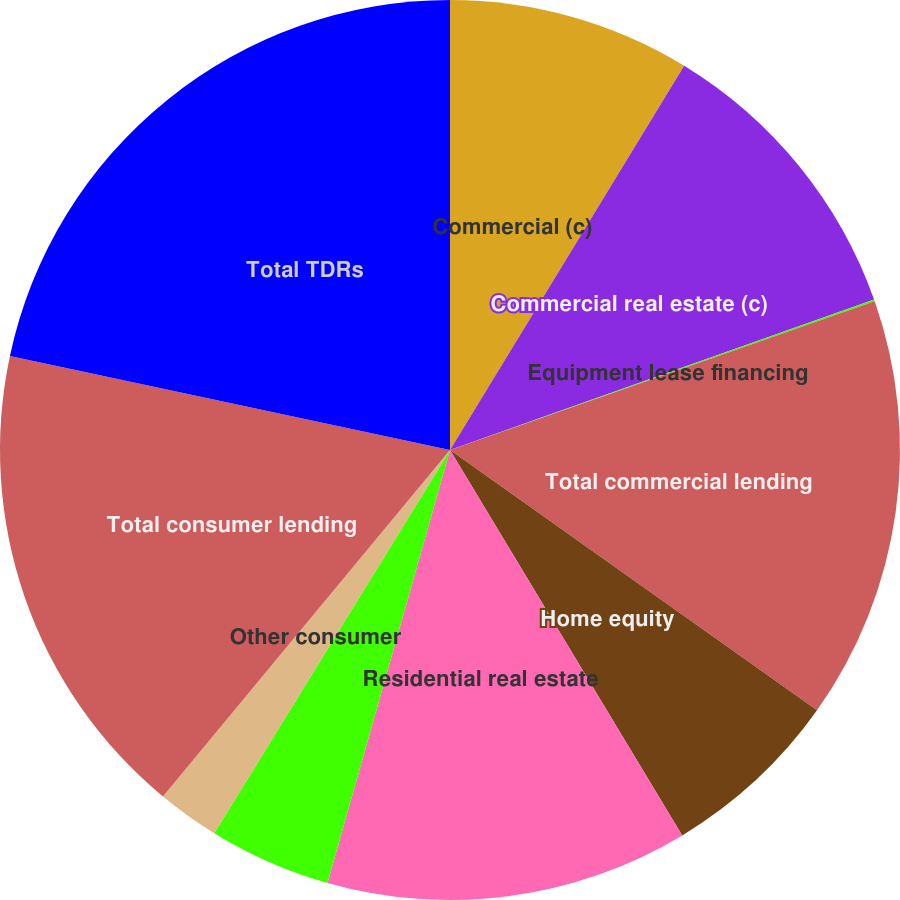Convert chart. <chart><loc_0><loc_0><loc_500><loc_500><pie_chart><fcel>Commercial (c)<fcel>Commercial real estate (c)<fcel>Equipment lease financing<fcel>Total commercial lending<fcel>Home equity<fcel>Residential real estate<fcel>Credit card<fcel>Other consumer<fcel>Total consumer lending<fcel>Total TDRs<nl><fcel>8.71%<fcel>10.86%<fcel>0.07%<fcel>15.18%<fcel>6.55%<fcel>13.02%<fcel>4.39%<fcel>2.23%<fcel>17.34%<fcel>21.65%<nl></chart> 